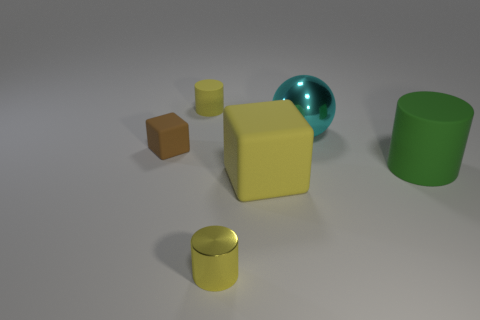Subtract 1 cylinders. How many cylinders are left? 2 Add 3 cyan metal blocks. How many objects exist? 9 Subtract all balls. How many objects are left? 5 Add 5 big things. How many big things are left? 8 Add 2 large blue balls. How many large blue balls exist? 2 Subtract 0 purple cylinders. How many objects are left? 6 Subtract all large metal spheres. Subtract all cyan spheres. How many objects are left? 4 